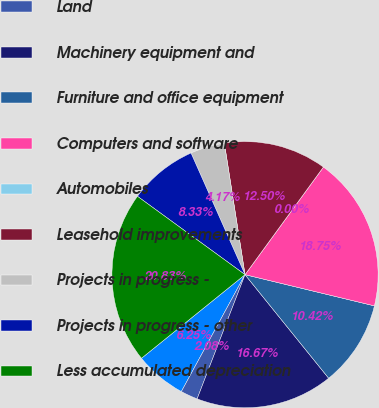Convert chart to OTSL. <chart><loc_0><loc_0><loc_500><loc_500><pie_chart><fcel>Buildings<fcel>Land<fcel>Machinery equipment and<fcel>Furniture and office equipment<fcel>Computers and software<fcel>Automobiles<fcel>Leasehold improvements<fcel>Projects in progress -<fcel>Projects in progress - other<fcel>Less accumulated depreciation<nl><fcel>6.25%<fcel>2.08%<fcel>16.67%<fcel>10.42%<fcel>18.75%<fcel>0.0%<fcel>12.5%<fcel>4.17%<fcel>8.33%<fcel>20.83%<nl></chart> 